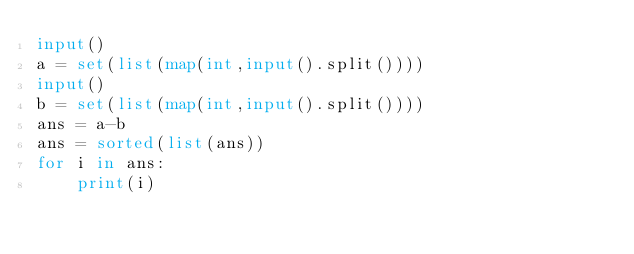Convert code to text. <code><loc_0><loc_0><loc_500><loc_500><_Python_>input()
a = set(list(map(int,input().split())))
input()
b = set(list(map(int,input().split())))
ans = a-b
ans = sorted(list(ans))
for i in ans:
    print(i)

</code> 